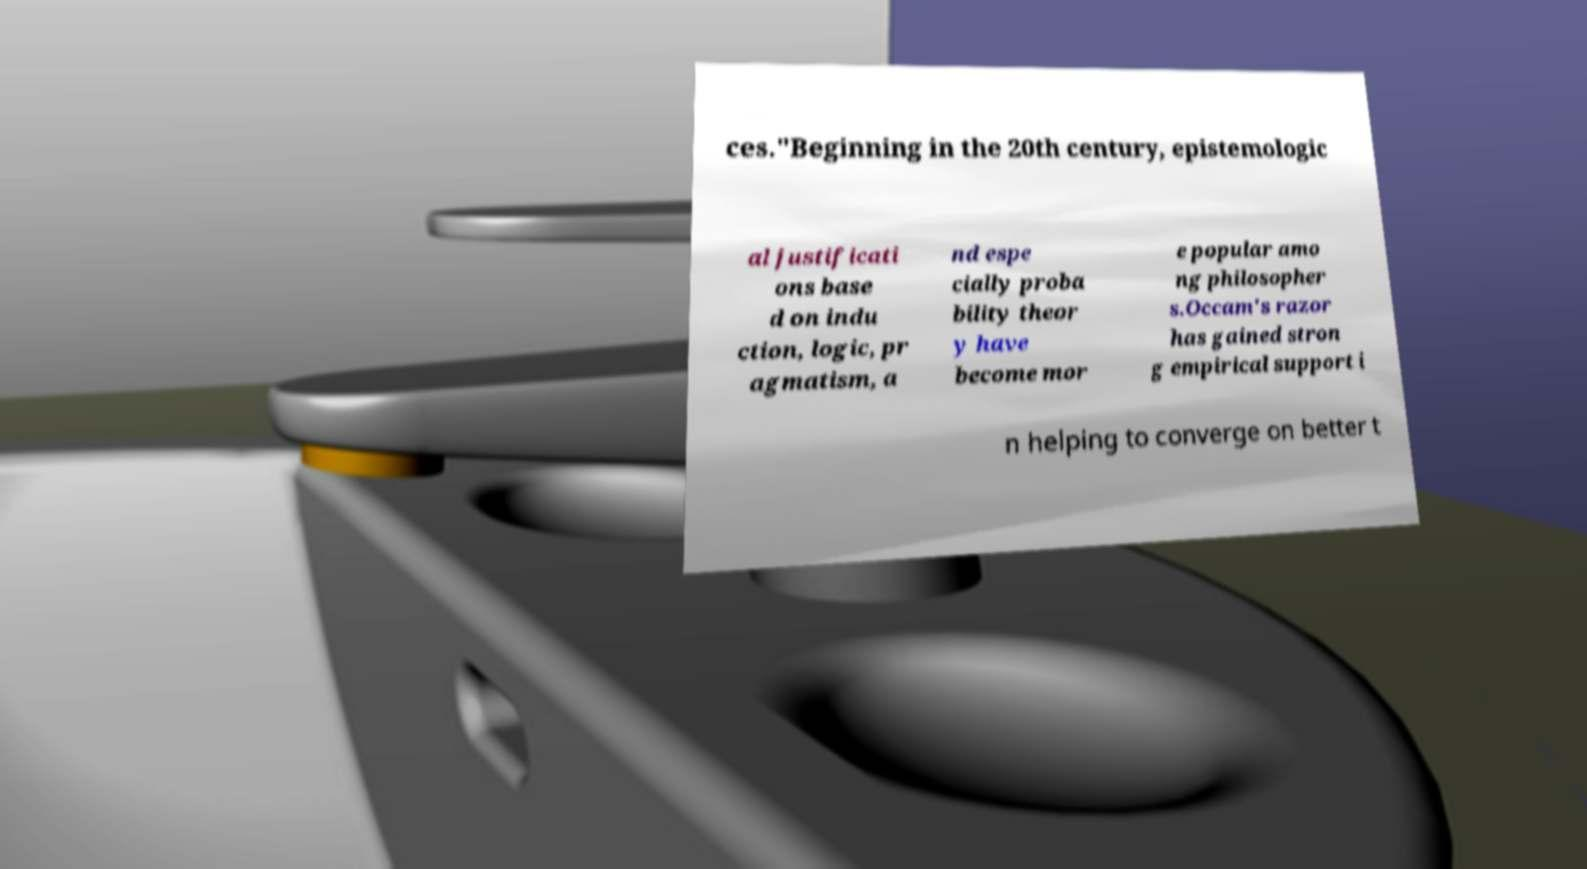What messages or text are displayed in this image? I need them in a readable, typed format. ces."Beginning in the 20th century, epistemologic al justificati ons base d on indu ction, logic, pr agmatism, a nd espe cially proba bility theor y have become mor e popular amo ng philosopher s.Occam's razor has gained stron g empirical support i n helping to converge on better t 